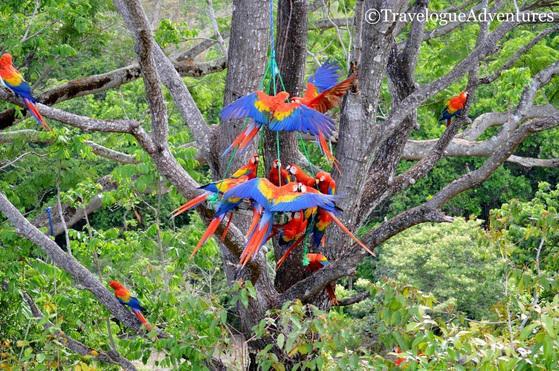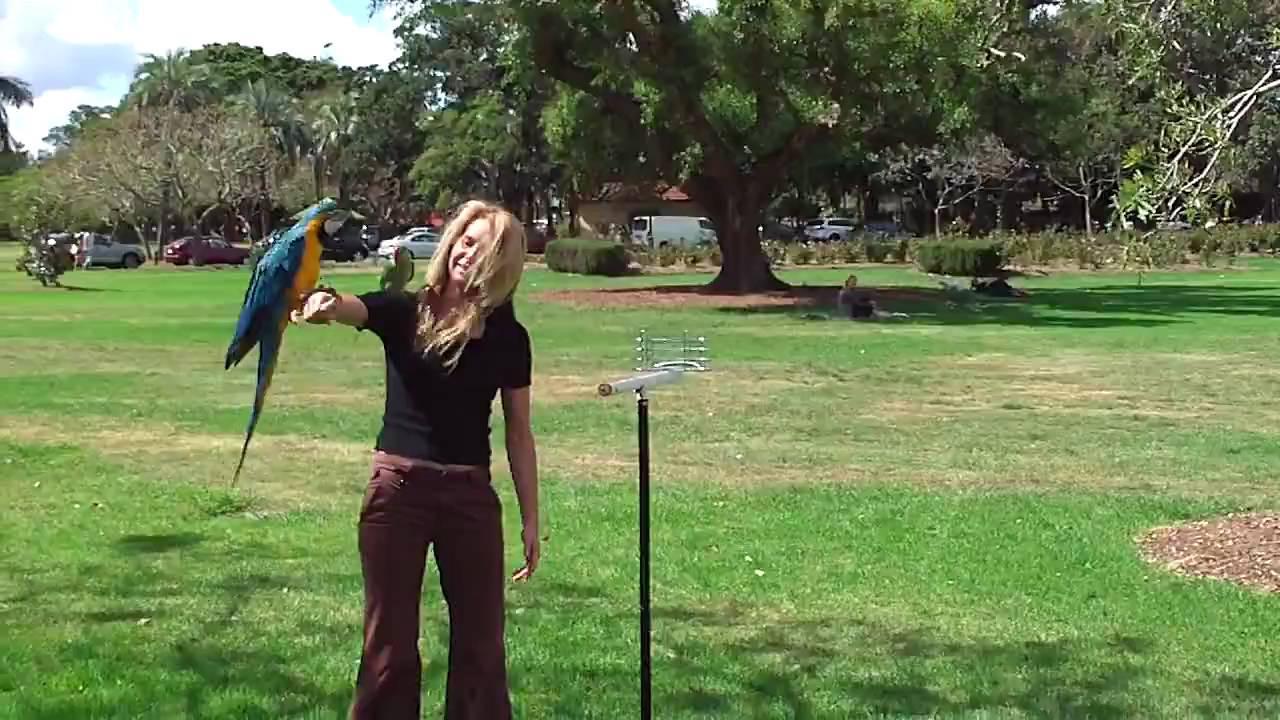The first image is the image on the left, the second image is the image on the right. For the images shown, is this caption "An image shows a bird perched on a person's extended hand." true? Answer yes or no. Yes. 